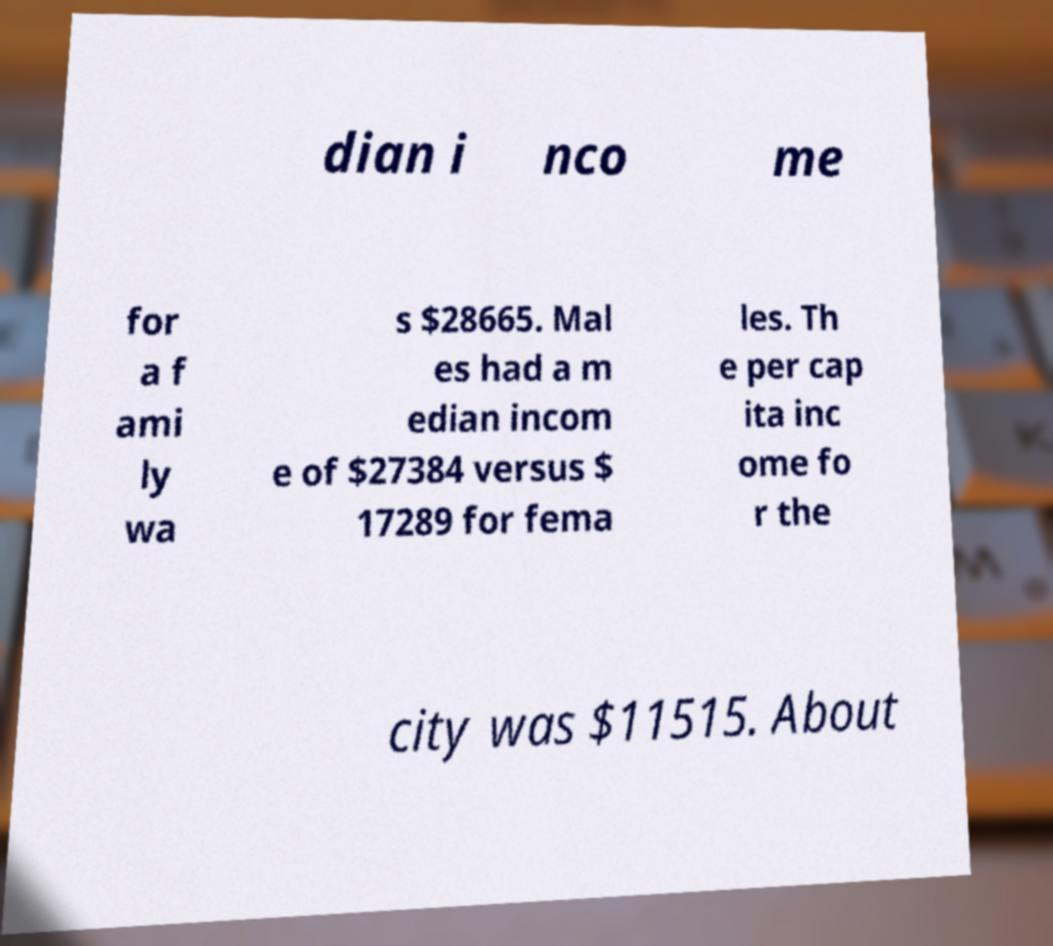What messages or text are displayed in this image? I need them in a readable, typed format. dian i nco me for a f ami ly wa s $28665. Mal es had a m edian incom e of $27384 versus $ 17289 for fema les. Th e per cap ita inc ome fo r the city was $11515. About 